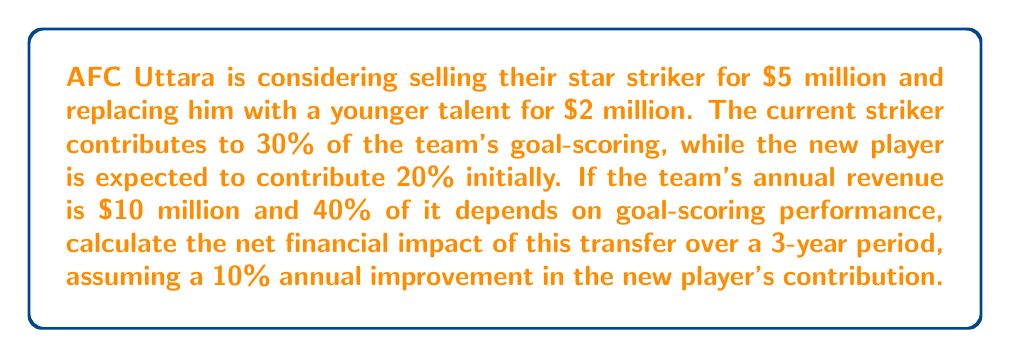Solve this math problem. Let's break this down step-by-step:

1) Calculate the current revenue attributable to goal-scoring:
   $10 million × 40% = $4 million

2) Calculate the current striker's contribution to revenue:
   $4 million × 30% = $1.2 million per year

3) Calculate the new player's contribution to revenue:
   Year 1: $4 million × 20% = $0.8 million
   Year 2: $4 million × (20% + 10%) = $1.2 million
   Year 3: $4 million × (30% + 10%) = $1.6 million

4) Calculate the difference in revenue contribution over 3 years:
   Current striker: $1.2 million × 3 = $3.6 million
   New player: $0.8 million + $1.2 million + $1.6 million = $3.6 million
   Difference: $3.6 million - $3.6 million = $0

5) Calculate the net transfer cost:
   Selling price - Buying price = $5 million - $2 million = $3 million profit

6) The net financial impact is the sum of the transfer profit and the revenue difference:
   $3 million + $0 = $3 million

Therefore, the net financial impact over the 3-year period is a positive $3 million.
Answer: $3 million profit 